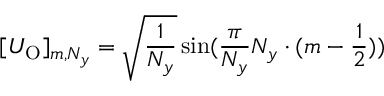<formula> <loc_0><loc_0><loc_500><loc_500>[ U _ { O } ] _ { m , N _ { y } } = \sqrt { \frac { 1 } { N _ { y } } } \sin ( \frac { \pi } { N _ { y } } N _ { y } \cdot ( m - \frac { 1 } { 2 } ) )</formula> 